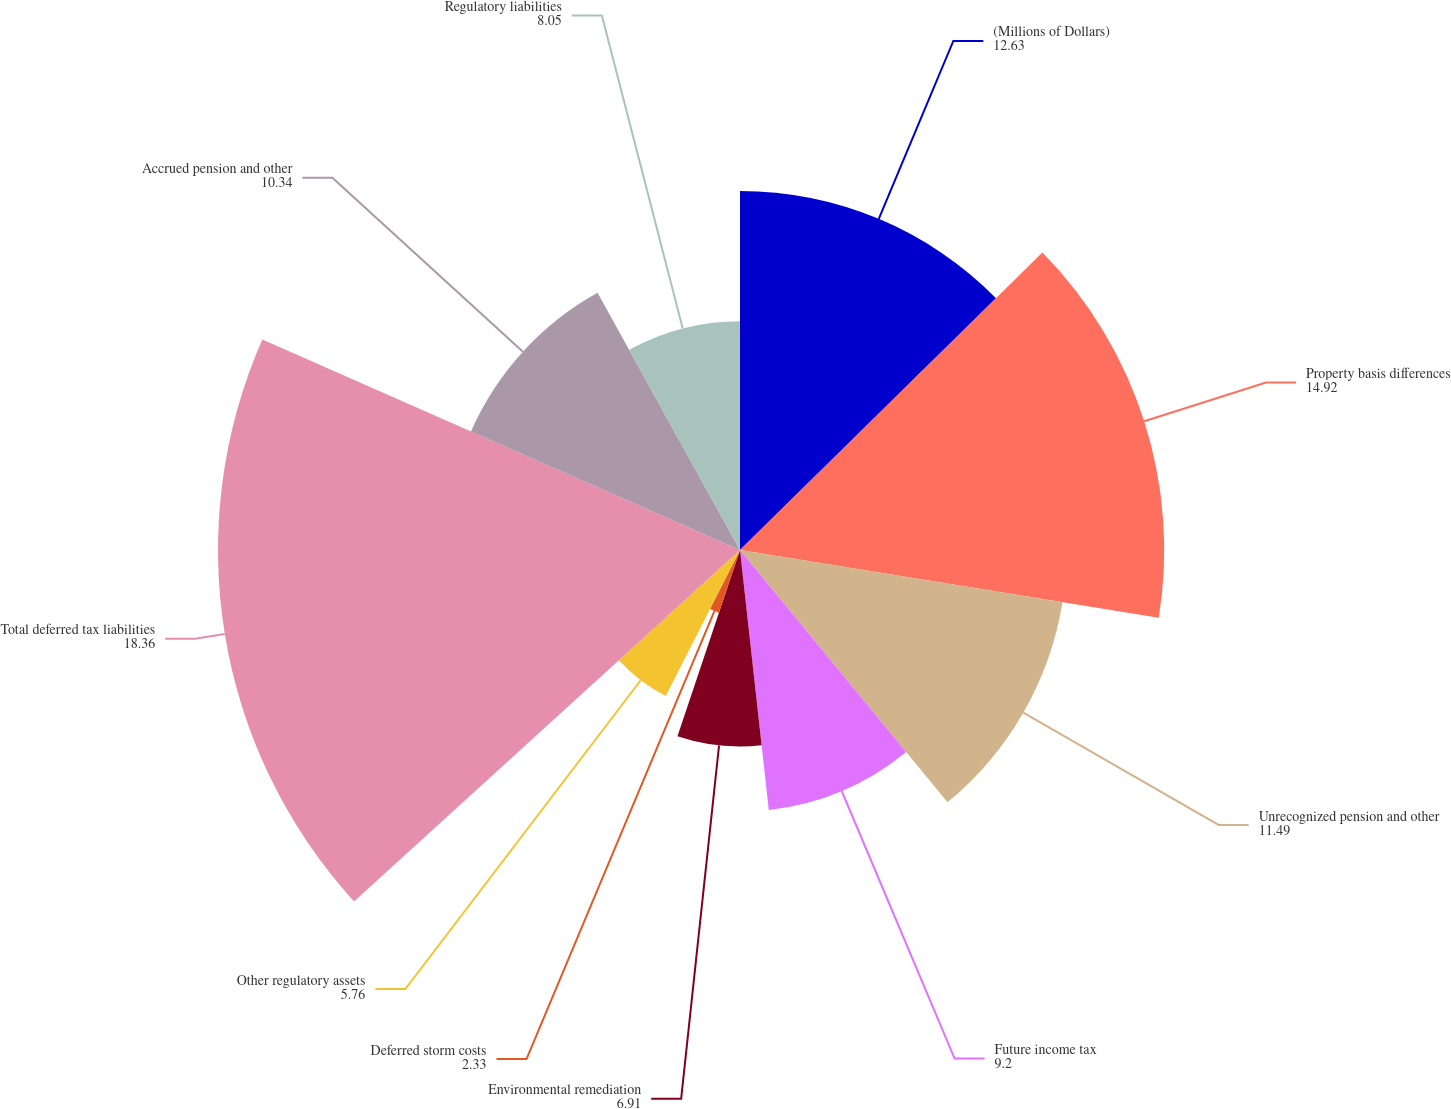Convert chart to OTSL. <chart><loc_0><loc_0><loc_500><loc_500><pie_chart><fcel>(Millions of Dollars)<fcel>Property basis differences<fcel>Unrecognized pension and other<fcel>Future income tax<fcel>Environmental remediation<fcel>Deferred storm costs<fcel>Other regulatory assets<fcel>Total deferred tax liabilities<fcel>Accrued pension and other<fcel>Regulatory liabilities<nl><fcel>12.63%<fcel>14.92%<fcel>11.49%<fcel>9.2%<fcel>6.91%<fcel>2.33%<fcel>5.76%<fcel>18.36%<fcel>10.34%<fcel>8.05%<nl></chart> 